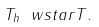<formula> <loc_0><loc_0><loc_500><loc_500>T _ { h } \ w s t a r T .</formula> 